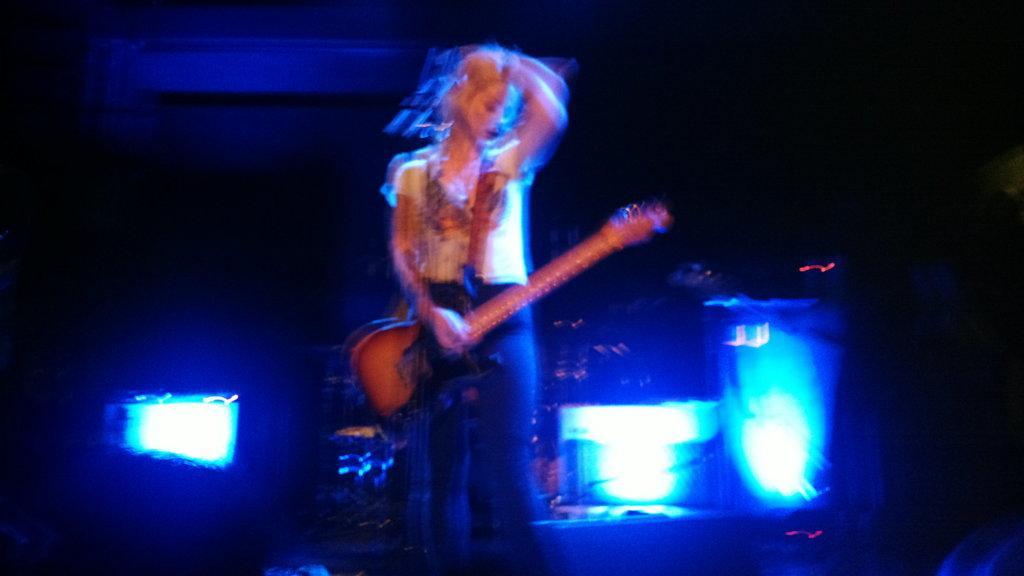Can you describe this image briefly? In this picture there is a woman holding a guitar. There are some lights in the background. 